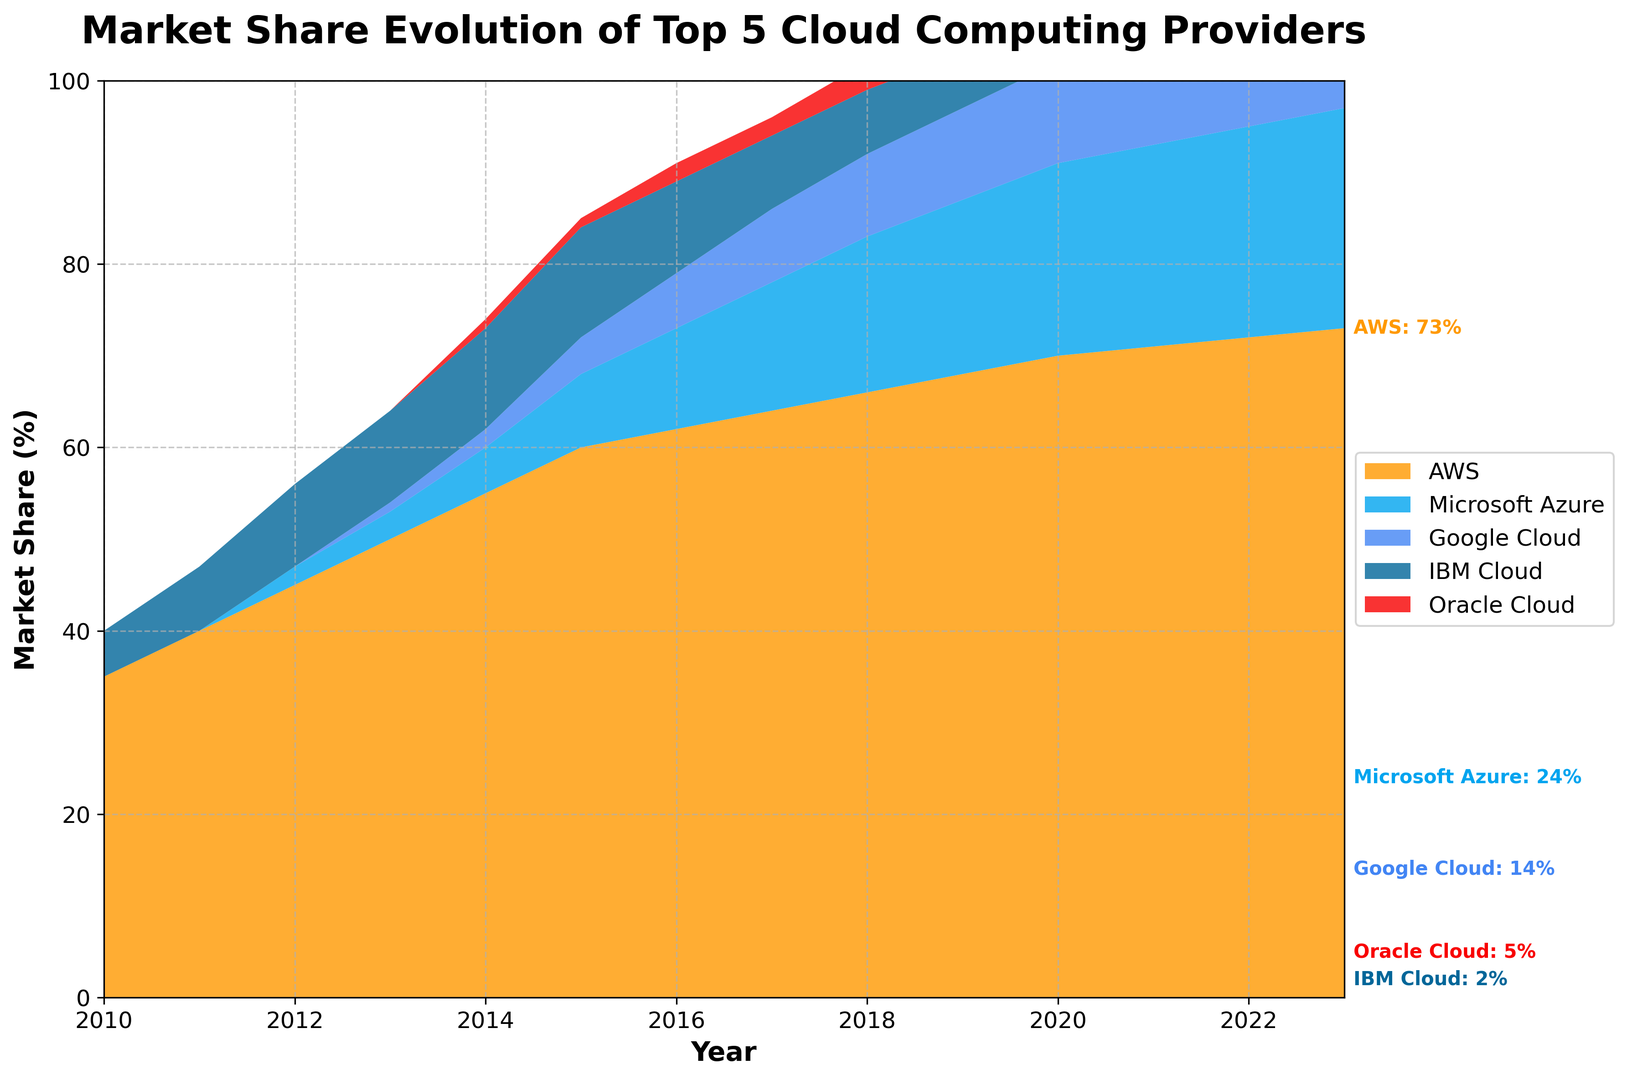When does Microsoft Azure first appear on the chart? Microsoft Azure first appears on the chart in 2012. This can be seen from the figure where its visual representation starts from that year.
Answer: 2012 Which provider shows a consistent decline in market share over the years? IBM Cloud shows a consistent decline in market share over the years. This can be observed as its area decreases from 2016 to 2023.
Answer: IBM Cloud What is the market share difference between Amazon Web Services (AWS) and Oracle Cloud in 2023? In 2023, AWS has a market share of 73% and Oracle Cloud has a 5% share. The difference is calculated as 73% - 5%.
Answer: 68% How did the market share of Google Cloud change from 2016 to 2023? In 2016, Google Cloud's market share was 6%, and it increased to 14% by 2023. The change in market share is 14% - 6%.
Answer: 8% Which provider had the second-highest market share in 2014? In 2014, the second-highest market share is represented by Microsoft Azure. This is evident from the visual height of the respective area under Microsoft Azure in that year.
Answer: Microsoft Azure By how much did AWS's market share increase from 2010 to 2023? AWS's market share in 2010 was 35% and it increased to 73% in 2023. The difference is calculated as 73% - 35%.
Answer: 38% Which year did Google Cloud first surpass IBM Cloud in market share? Google Cloud first surpassed IBM Cloud in market share in 2020. This is visible from the figure where Google Cloud's area becomes larger than IBM Cloud's area.
Answer: 2020 How does Oracle Cloud's market share in 2023 compare to its share in 2010? Oracle Cloud's market share in 2010 was 0% and increased to 5% in 2023. The difference is 5% - 0%.
Answer: 5% What can you infer about the overall market share trend for Microsoft Azure and Google Cloud from 2010 to 2023? Both Microsoft Azure and Google Cloud have shown an increasing trend in their market shares from 2010 to 2023. This is seen through the expanding areas under their respective sections on the chart over the years.
Answer: Increasing Which providers had their highest market share in 2023? AWS, Microsoft Azure, Google Cloud, and Oracle Cloud all had their highest market share in 2023. This is evident since the areas under their sections are largest in 2023.
Answer: AWS, Microsoft Azure, Google Cloud, Oracle Cloud 